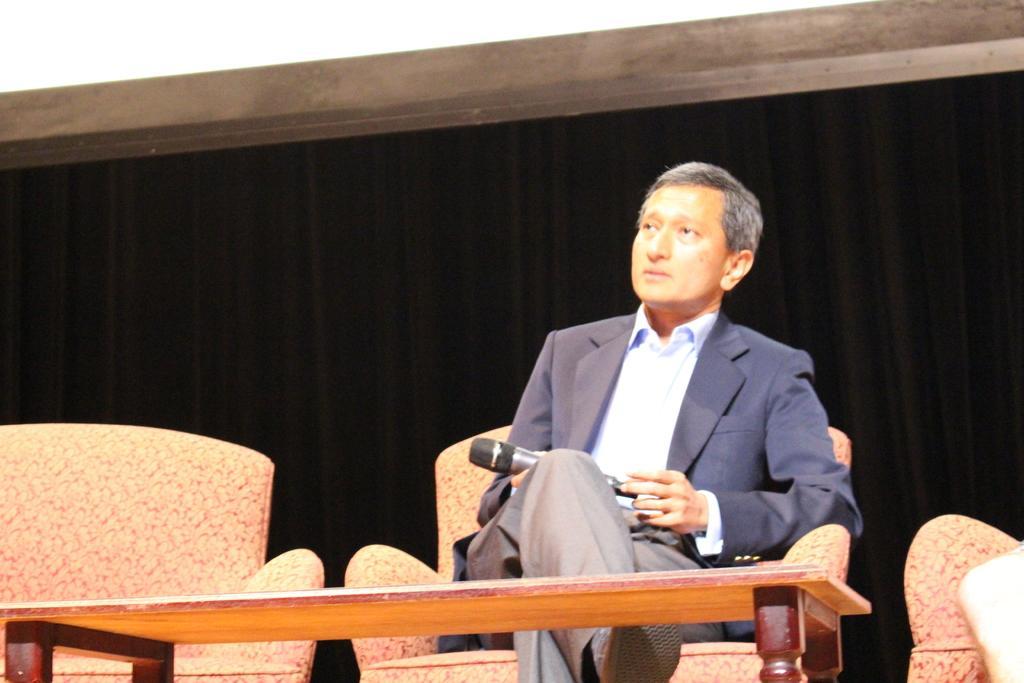In one or two sentences, can you explain what this image depicts? In this picture there is a man sitting on the sofa and holding a mike. He is wearing a blue blazer and grey trousers. On either side of him, there are sofas which are empty. Before him there is a table. In the background there is a curtain. 